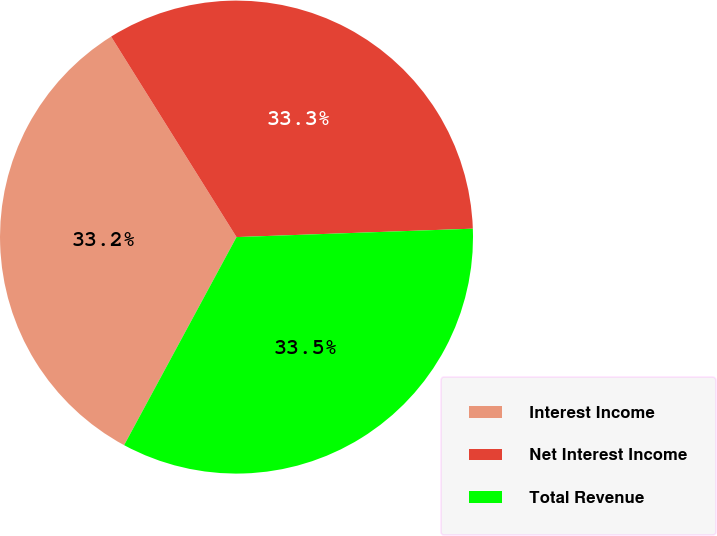Convert chart. <chart><loc_0><loc_0><loc_500><loc_500><pie_chart><fcel>Interest Income<fcel>Net Interest Income<fcel>Total Revenue<nl><fcel>33.22%<fcel>33.33%<fcel>33.45%<nl></chart> 